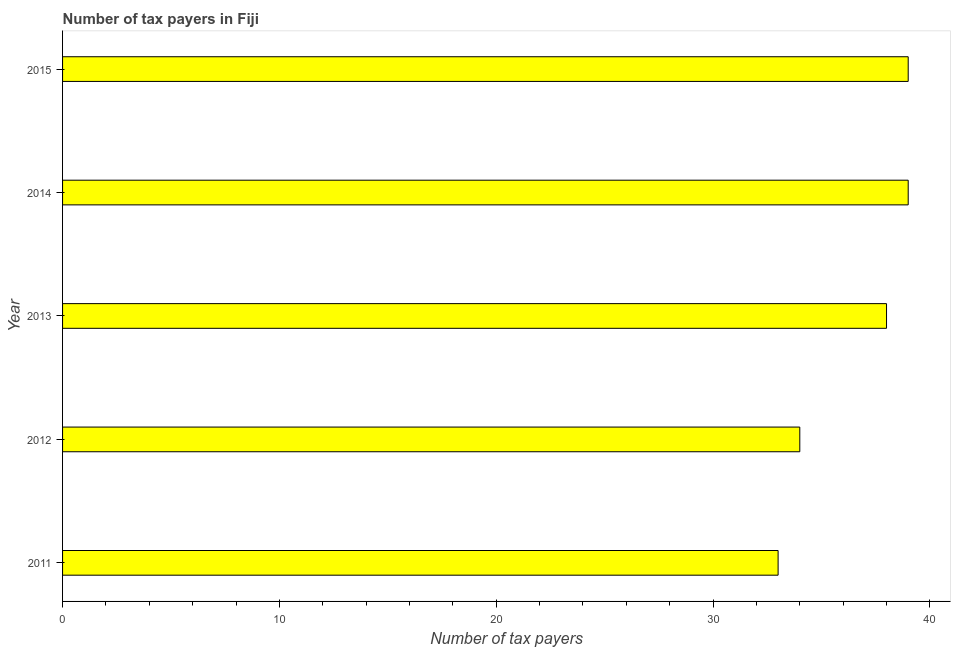Does the graph contain grids?
Provide a short and direct response. No. What is the title of the graph?
Make the answer very short. Number of tax payers in Fiji. What is the label or title of the X-axis?
Ensure brevity in your answer.  Number of tax payers. What is the label or title of the Y-axis?
Provide a succinct answer. Year. Across all years, what is the maximum number of tax payers?
Give a very brief answer. 39. Across all years, what is the minimum number of tax payers?
Your answer should be very brief. 33. In which year was the number of tax payers minimum?
Ensure brevity in your answer.  2011. What is the sum of the number of tax payers?
Your response must be concise. 183. What is the difference between the number of tax payers in 2011 and 2013?
Keep it short and to the point. -5. What is the average number of tax payers per year?
Offer a terse response. 36. Do a majority of the years between 2015 and 2013 (inclusive) have number of tax payers greater than 22 ?
Offer a terse response. Yes. Is the difference between the number of tax payers in 2014 and 2015 greater than the difference between any two years?
Give a very brief answer. No. What is the difference between the highest and the second highest number of tax payers?
Provide a short and direct response. 0. In how many years, is the number of tax payers greater than the average number of tax payers taken over all years?
Offer a very short reply. 3. How many bars are there?
Offer a very short reply. 5. How many years are there in the graph?
Ensure brevity in your answer.  5. What is the difference between two consecutive major ticks on the X-axis?
Make the answer very short. 10. Are the values on the major ticks of X-axis written in scientific E-notation?
Offer a terse response. No. What is the Number of tax payers in 2013?
Provide a succinct answer. 38. What is the Number of tax payers in 2014?
Ensure brevity in your answer.  39. What is the Number of tax payers in 2015?
Make the answer very short. 39. What is the difference between the Number of tax payers in 2011 and 2012?
Your answer should be compact. -1. What is the difference between the Number of tax payers in 2011 and 2014?
Provide a short and direct response. -6. What is the difference between the Number of tax payers in 2011 and 2015?
Give a very brief answer. -6. What is the difference between the Number of tax payers in 2012 and 2014?
Keep it short and to the point. -5. What is the difference between the Number of tax payers in 2012 and 2015?
Offer a terse response. -5. What is the difference between the Number of tax payers in 2013 and 2014?
Your response must be concise. -1. What is the ratio of the Number of tax payers in 2011 to that in 2013?
Ensure brevity in your answer.  0.87. What is the ratio of the Number of tax payers in 2011 to that in 2014?
Ensure brevity in your answer.  0.85. What is the ratio of the Number of tax payers in 2011 to that in 2015?
Your response must be concise. 0.85. What is the ratio of the Number of tax payers in 2012 to that in 2013?
Your answer should be very brief. 0.9. What is the ratio of the Number of tax payers in 2012 to that in 2014?
Your answer should be compact. 0.87. What is the ratio of the Number of tax payers in 2012 to that in 2015?
Your response must be concise. 0.87. What is the ratio of the Number of tax payers in 2013 to that in 2014?
Keep it short and to the point. 0.97. What is the ratio of the Number of tax payers in 2013 to that in 2015?
Your response must be concise. 0.97. What is the ratio of the Number of tax payers in 2014 to that in 2015?
Your answer should be very brief. 1. 